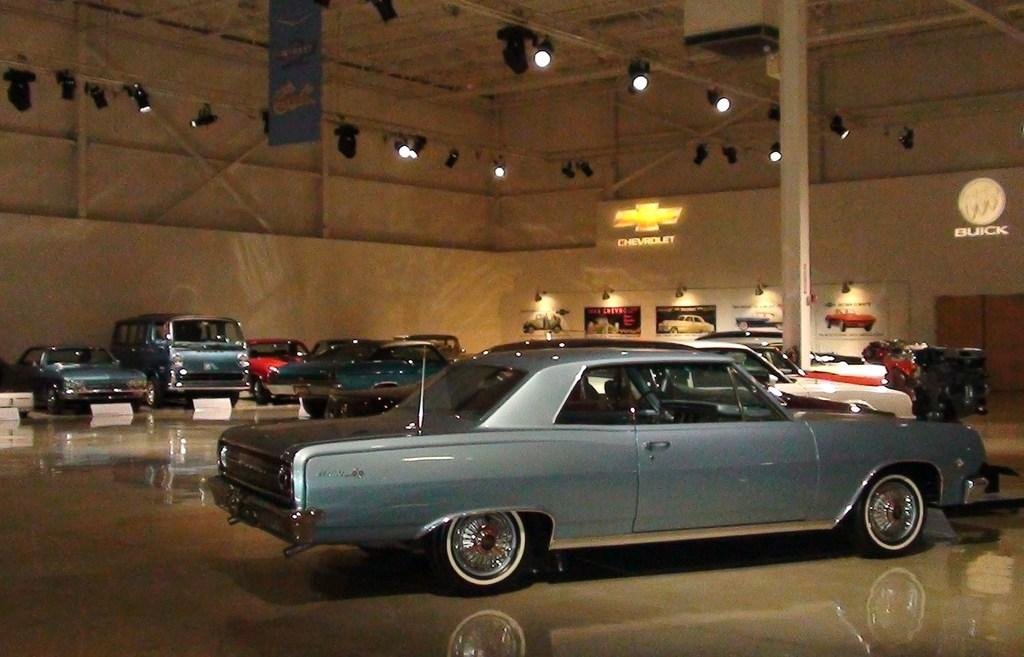What objects are on the floor in the image? There are cars on the floor in the image. What can be seen in the background of the image? There are lights in the background of the image. What is on the wall in the image? There are photo frames and symbols and letters on the wall in the image. How does the cap help the structure in the image? There is no cap or structure present in the image. 